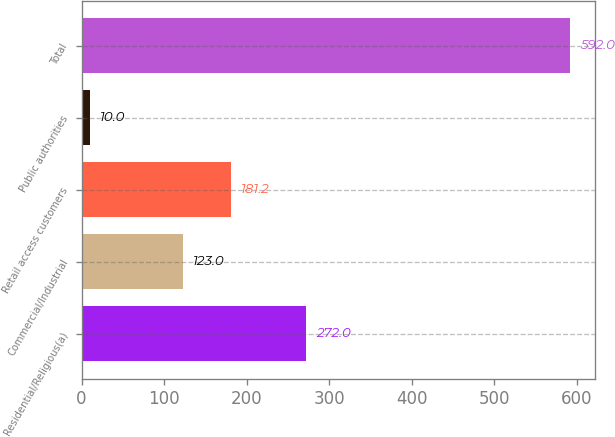<chart> <loc_0><loc_0><loc_500><loc_500><bar_chart><fcel>Residential/Religious(a)<fcel>Commercial/Industrial<fcel>Retail access customers<fcel>Public authorities<fcel>Total<nl><fcel>272<fcel>123<fcel>181.2<fcel>10<fcel>592<nl></chart> 